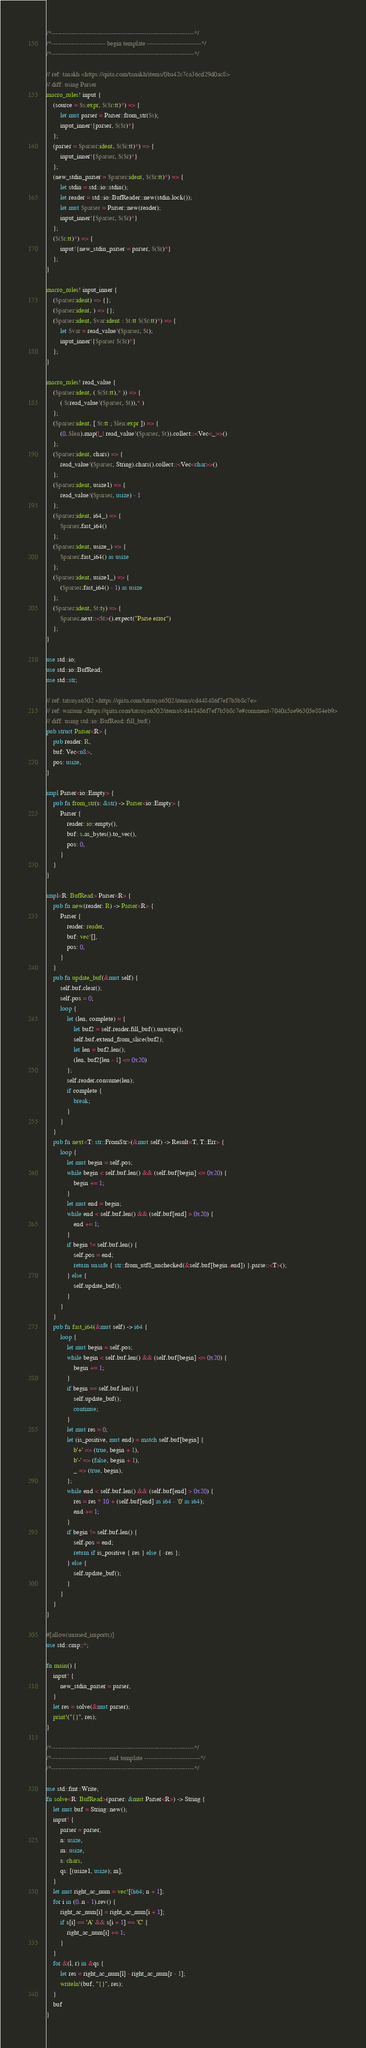<code> <loc_0><loc_0><loc_500><loc_500><_Rust_>/*------------------------------------------------------------------*/
/*------------------------- begin template -------------------------*/
/*------------------------------------------------------------------*/

// ref: tanakh <https://qiita.com/tanakh/items/0ba42c7ca36cd29d0ac8>
// diff: using Parser
macro_rules! input {
    (source = $s:expr, $($r:tt)*) => {
        let mut parser = Parser::from_str($s);
        input_inner!{parser, $($r)*}
    };
    (parser = $parser:ident, $($r:tt)*) => {
        input_inner!{$parser, $($r)*}
    };
    (new_stdin_parser = $parser:ident, $($r:tt)*) => {
        let stdin = std::io::stdin();
        let reader = std::io::BufReader::new(stdin.lock());
        let mut $parser = Parser::new(reader);
        input_inner!{$parser, $($r)*}
    };
    ($($r:tt)*) => {
        input!{new_stdin_parser = parser, $($r)*}
    };
}

macro_rules! input_inner {
    ($parser:ident) => {};
    ($parser:ident, ) => {};
    ($parser:ident, $var:ident : $t:tt $($r:tt)*) => {
        let $var = read_value!($parser, $t);
        input_inner!{$parser $($r)*}
    };
}

macro_rules! read_value {
    ($parser:ident, ( $($t:tt),* )) => {
        ( $(read_value!($parser, $t)),* )
    };
    ($parser:ident, [ $t:tt ; $len:expr ]) => {
        (0..$len).map(|_| read_value!($parser, $t)).collect::<Vec<_>>()
    };
    ($parser:ident, chars) => {
        read_value!($parser, String).chars().collect::<Vec<char>>()
    };
    ($parser:ident, usize1) => {
        read_value!($parser, usize) - 1
    };
    ($parser:ident, i64_) => {
        $parser.fast_i64()
    };
    ($parser:ident, usize_) => {
        $parser.fast_i64() as usize
    };
    ($parser:ident, usize1_) => {
        ($parser.fast_i64() - 1) as usize
    };
    ($parser:ident, $t:ty) => {
        $parser.next::<$t>().expect("Parse error")
    };
}

use std::io;
use std::io::BufRead;
use std::str;

// ref: tatsuya6502 <https://qiita.com/tatsuya6502/items/cd448486f7ef7b5b8c7e>
// ref: wariuni <https://qiita.com/tatsuya6502/items/cd448486f7ef7b5b8c7e#comment-7040a5ae96305e884eb9>
// diff: using std::io::BufRead::fill_buf()
pub struct Parser<R> {
    pub reader: R,
    buf: Vec<u8>,
    pos: usize,
}

impl Parser<io::Empty> {
    pub fn from_str(s: &str) -> Parser<io::Empty> {
        Parser {
            reader: io::empty(),
            buf: s.as_bytes().to_vec(),
            pos: 0,
        }
    }
}

impl<R: BufRead> Parser<R> {
    pub fn new(reader: R) -> Parser<R> {
        Parser {
            reader: reader,
            buf: vec![],
            pos: 0,
        }
    }
    pub fn update_buf(&mut self) {
        self.buf.clear();
        self.pos = 0;
        loop {
            let (len, complete) = {
                let buf2 = self.reader.fill_buf().unwrap();
                self.buf.extend_from_slice(buf2);
                let len = buf2.len();
                (len, buf2[len - 1] <= 0x20)
            };
            self.reader.consume(len);
            if complete {
                break;
            }
        }
    }
    pub fn next<T: str::FromStr>(&mut self) -> Result<T, T::Err> {
        loop {
            let mut begin = self.pos;
            while begin < self.buf.len() && (self.buf[begin] <= 0x20) {
                begin += 1;
            }
            let mut end = begin;
            while end < self.buf.len() && (self.buf[end] > 0x20) {
                end += 1;
            }
            if begin != self.buf.len() {
                self.pos = end;
                return unsafe { str::from_utf8_unchecked(&self.buf[begin..end]) }.parse::<T>();
            } else {
                self.update_buf();
            }
        }
    }
    pub fn fast_i64(&mut self) -> i64 {
        loop {
            let mut begin = self.pos;
            while begin < self.buf.len() && (self.buf[begin] <= 0x20) {
                begin += 1;
            }
            if begin == self.buf.len() {
                self.update_buf();
                continue;
            }
            let mut res = 0;
            let (is_positive, mut end) = match self.buf[begin] {
                b'+' => (true, begin + 1),
                b'-' => (false, begin + 1),
                _ => (true, begin),
            };
            while end < self.buf.len() && (self.buf[end] > 0x20) {
                res = res * 10 + (self.buf[end] as i64 - '0' as i64);
                end += 1;
            }
            if begin != self.buf.len() {
                self.pos = end;
                return if is_positive { res } else { -res };
            } else {
                self.update_buf();
            }
        }
    }
}

#[allow(unused_imports)]
use std::cmp::*;

fn main() {
    input! {
        new_stdin_parser = parser,
    }
    let res = solve(&mut parser);
    print!("{}", res);
}

/*------------------------------------------------------------------*/
/*-------------------------- end template --------------------------*/
/*------------------------------------------------------------------*/

use std::fmt::Write;
fn solve<R: BufRead>(parser: &mut Parser<R>) -> String {
    let mut buf = String::new();
    input! {
        parser = parser,
        n: usize,
        m: usize,
        s: chars,
        qs: [(usize1, usize); m],
    }
    let mut right_ac_num = vec![0i64; n + 1];
    for i in (0..n - 1).rev() {
        right_ac_num[i] = right_ac_num[i + 1];
        if s[i] == 'A' && s[i + 1] == 'C' {
            right_ac_num[i] += 1;
        }
    }
    for &(l, r) in &qs {
        let res = right_ac_num[l] - right_ac_num[r - 1];
        writeln!(buf, "{}", res);
    }
    buf
}
</code> 